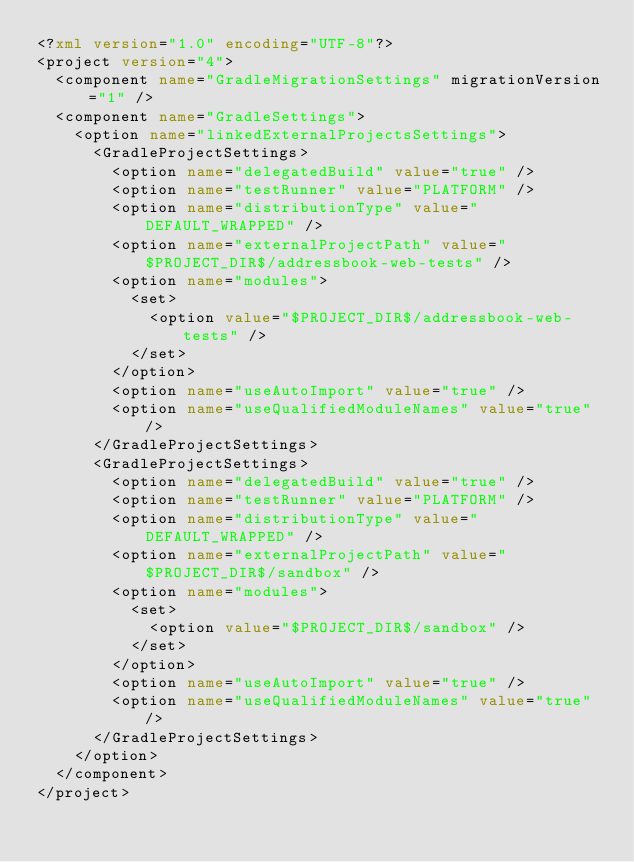<code> <loc_0><loc_0><loc_500><loc_500><_XML_><?xml version="1.0" encoding="UTF-8"?>
<project version="4">
  <component name="GradleMigrationSettings" migrationVersion="1" />
  <component name="GradleSettings">
    <option name="linkedExternalProjectsSettings">
      <GradleProjectSettings>
        <option name="delegatedBuild" value="true" />
        <option name="testRunner" value="PLATFORM" />
        <option name="distributionType" value="DEFAULT_WRAPPED" />
        <option name="externalProjectPath" value="$PROJECT_DIR$/addressbook-web-tests" />
        <option name="modules">
          <set>
            <option value="$PROJECT_DIR$/addressbook-web-tests" />
          </set>
        </option>
        <option name="useAutoImport" value="true" />
        <option name="useQualifiedModuleNames" value="true" />
      </GradleProjectSettings>
      <GradleProjectSettings>
        <option name="delegatedBuild" value="true" />
        <option name="testRunner" value="PLATFORM" />
        <option name="distributionType" value="DEFAULT_WRAPPED" />
        <option name="externalProjectPath" value="$PROJECT_DIR$/sandbox" />
        <option name="modules">
          <set>
            <option value="$PROJECT_DIR$/sandbox" />
          </set>
        </option>
        <option name="useAutoImport" value="true" />
        <option name="useQualifiedModuleNames" value="true" />
      </GradleProjectSettings>
    </option>
  </component>
</project></code> 